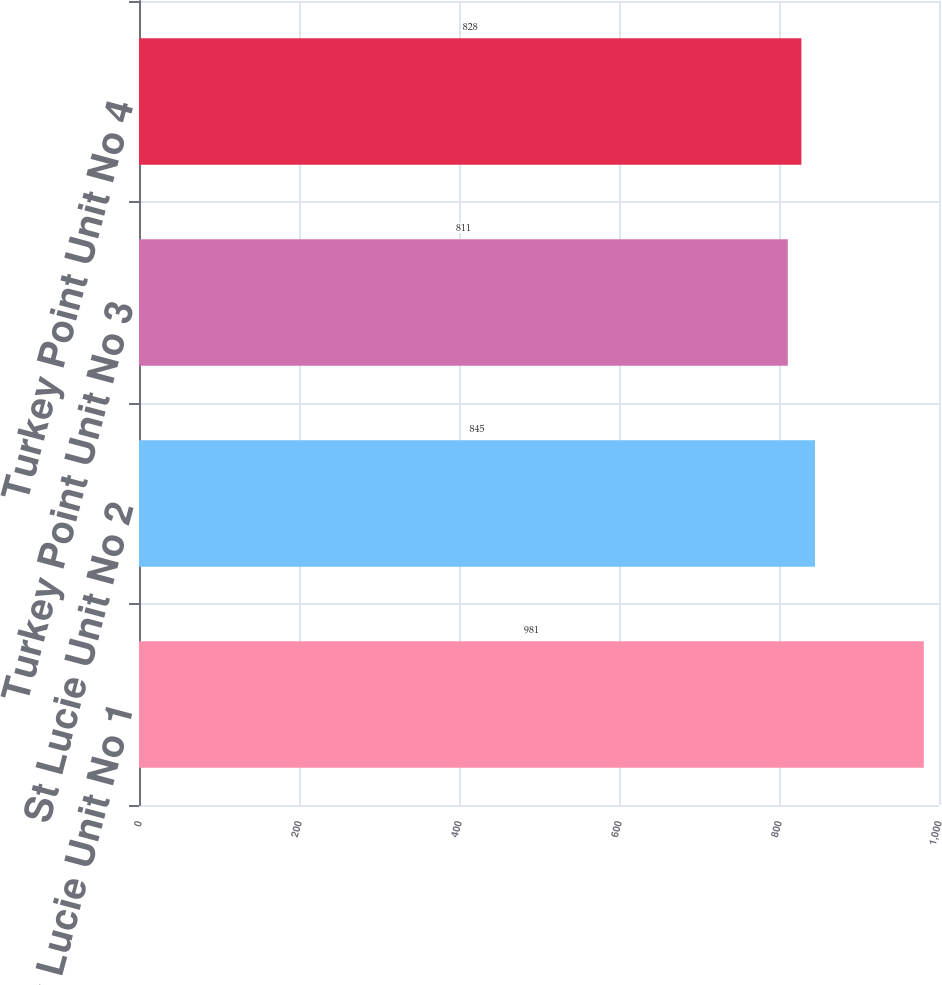<chart> <loc_0><loc_0><loc_500><loc_500><bar_chart><fcel>St Lucie Unit No 1<fcel>St Lucie Unit No 2<fcel>Turkey Point Unit No 3<fcel>Turkey Point Unit No 4<nl><fcel>981<fcel>845<fcel>811<fcel>828<nl></chart> 